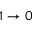<formula> <loc_0><loc_0><loc_500><loc_500>1 \rightarrow 0</formula> 